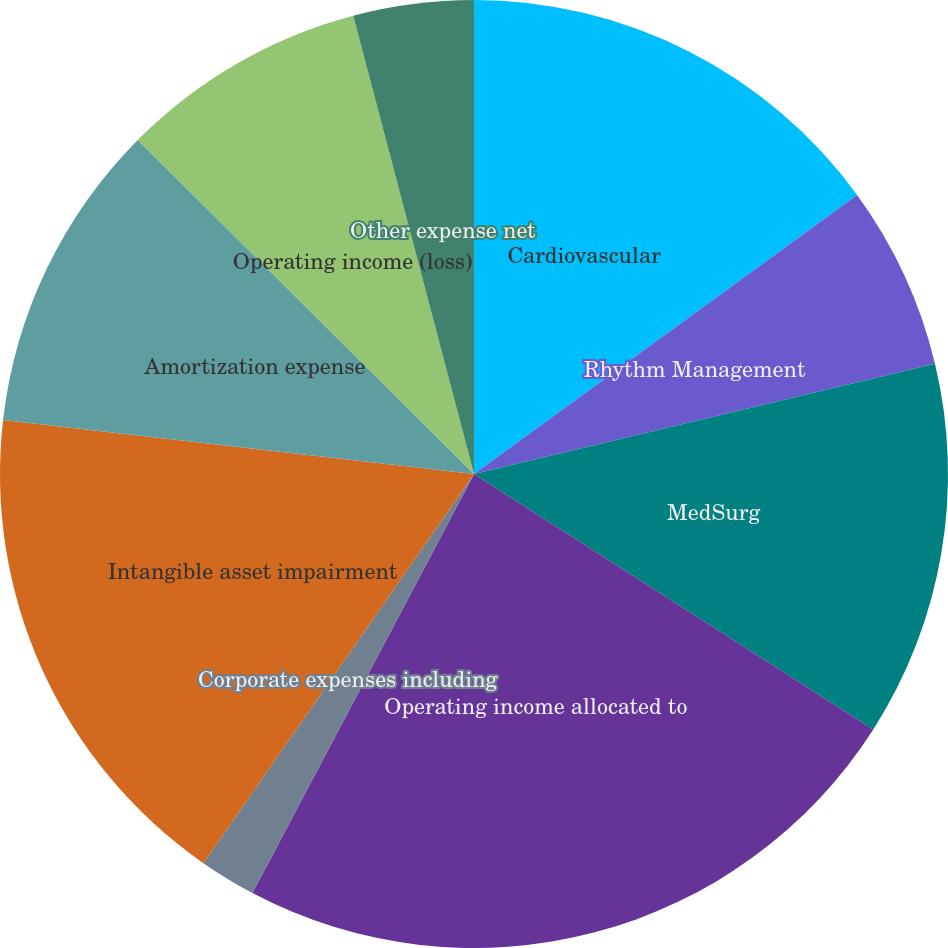<chart> <loc_0><loc_0><loc_500><loc_500><pie_chart><fcel>Cardiovascular<fcel>Rhythm Management<fcel>MedSurg<fcel>Operating income allocated to<fcel>Corporate expenses including<fcel>Intangible asset impairment<fcel>Amortization expense<fcel>Operating income (loss)<fcel>Other expense net<nl><fcel>14.98%<fcel>6.28%<fcel>12.8%<fcel>23.68%<fcel>1.93%<fcel>17.15%<fcel>10.63%<fcel>8.45%<fcel>4.1%<nl></chart> 